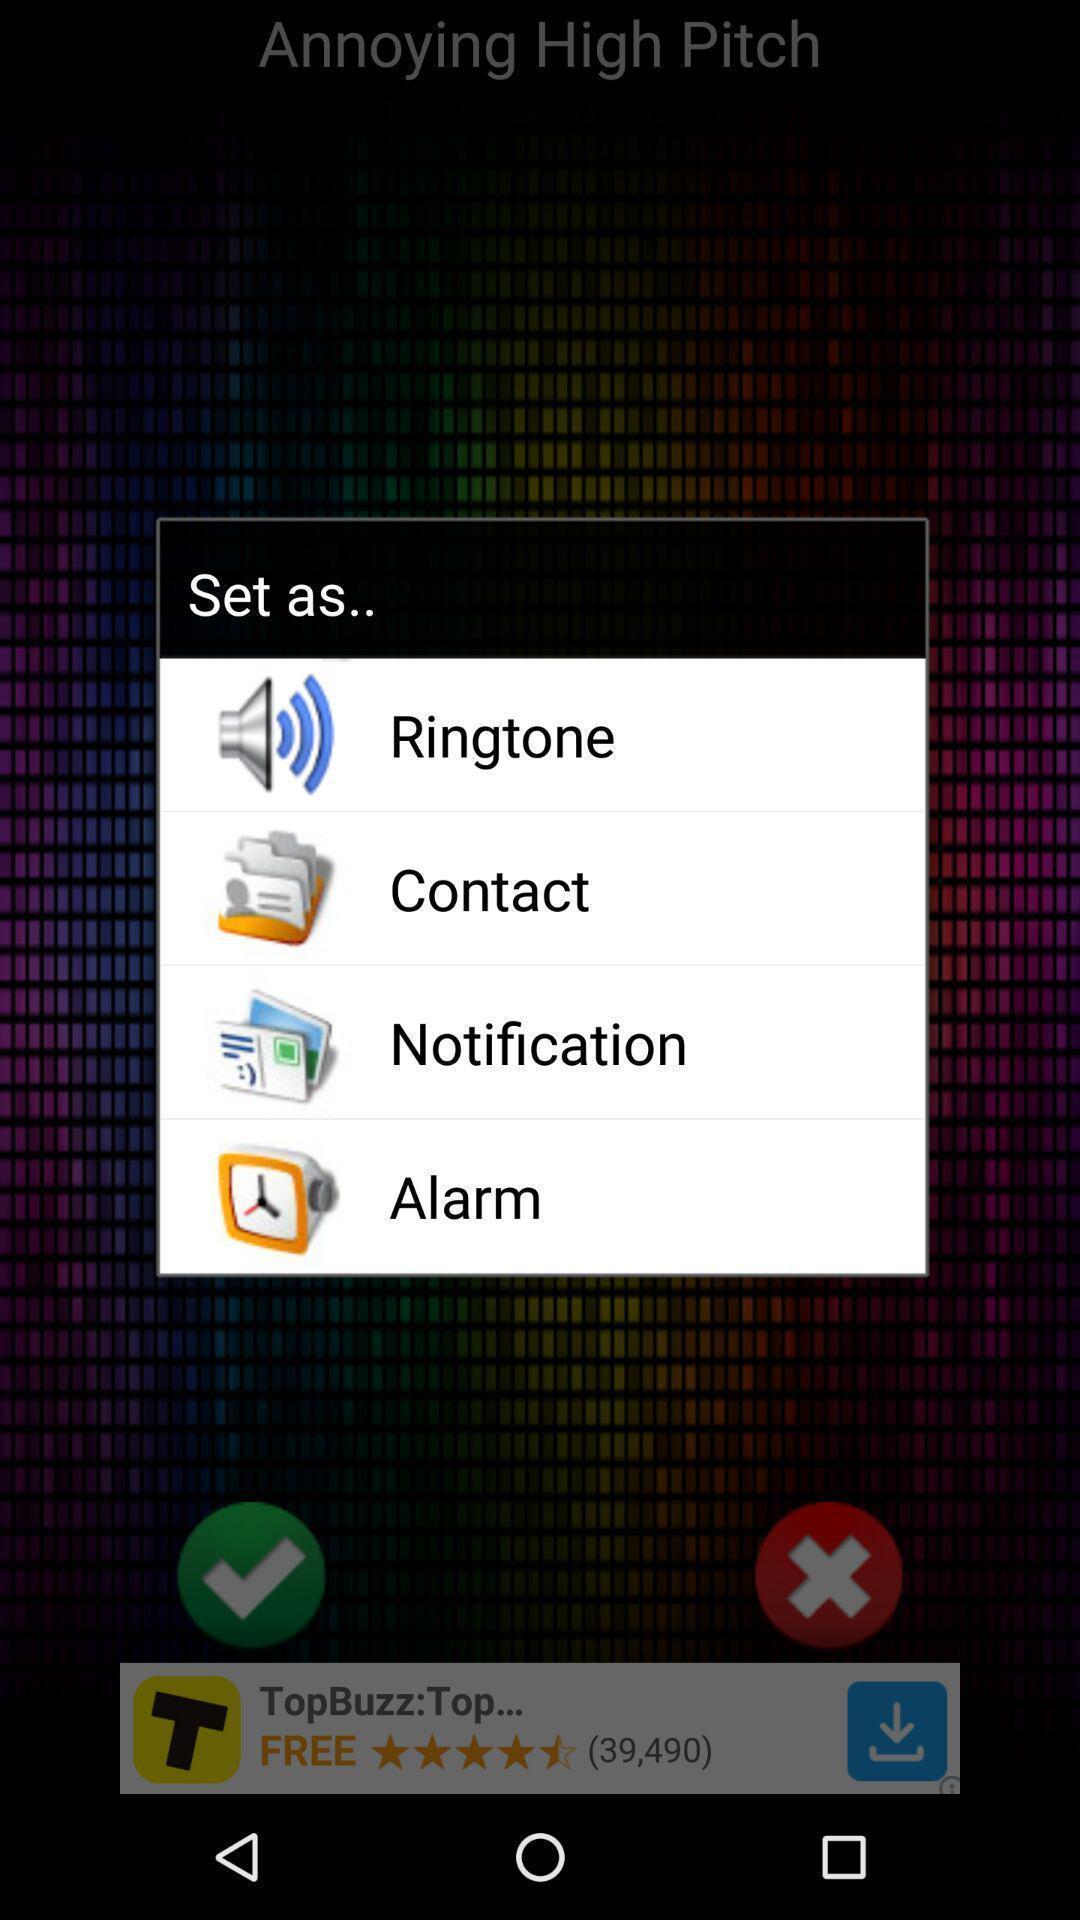Summarize the main components in this picture. Screen displaying the list of options to set as. 